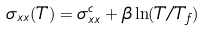<formula> <loc_0><loc_0><loc_500><loc_500>\sigma _ { x x } ( T ) = \sigma _ { x x } ^ { c } + \beta \ln ( T / T _ { f } )</formula> 